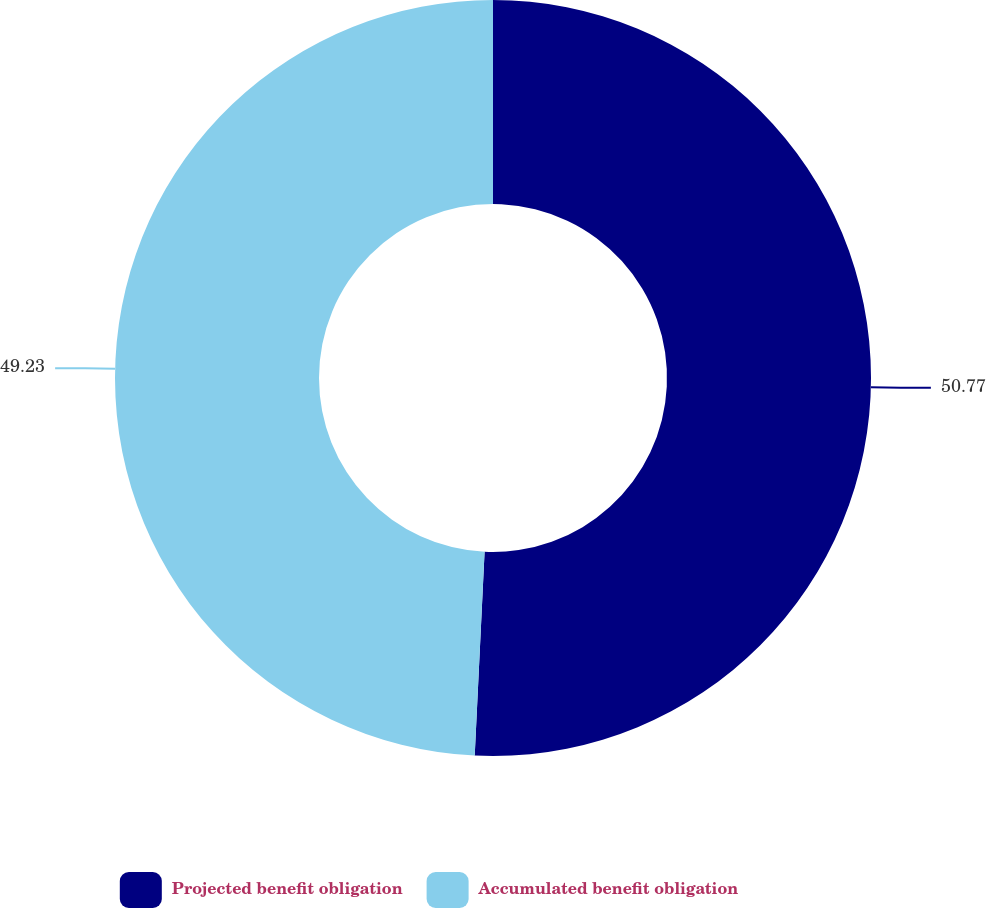Convert chart to OTSL. <chart><loc_0><loc_0><loc_500><loc_500><pie_chart><fcel>Projected benefit obligation<fcel>Accumulated benefit obligation<nl><fcel>50.77%<fcel>49.23%<nl></chart> 